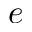Convert formula to latex. <formula><loc_0><loc_0><loc_500><loc_500>e</formula> 